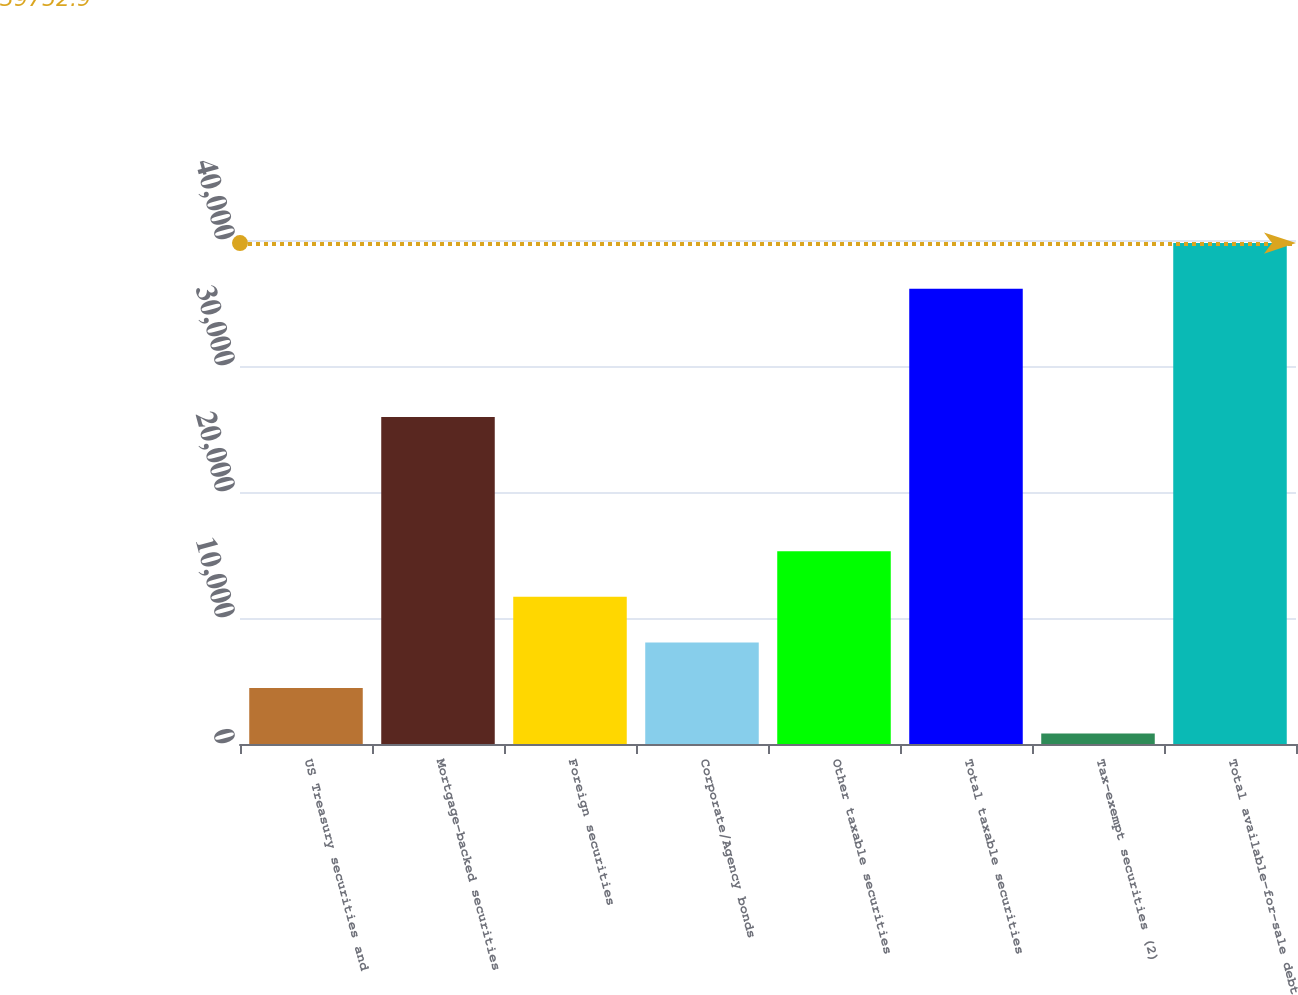Convert chart to OTSL. <chart><loc_0><loc_0><loc_500><loc_500><bar_chart><fcel>US Treasury securities and<fcel>Mortgage-backed securities<fcel>Foreign securities<fcel>Corporate/Agency bonds<fcel>Other taxable securities<fcel>Total taxable securities<fcel>Tax-exempt securities (2)<fcel>Total available-for-sale debt<nl><fcel>4449.9<fcel>25953<fcel>11677.7<fcel>8063.8<fcel>15291.6<fcel>36139<fcel>836<fcel>39752.9<nl></chart> 